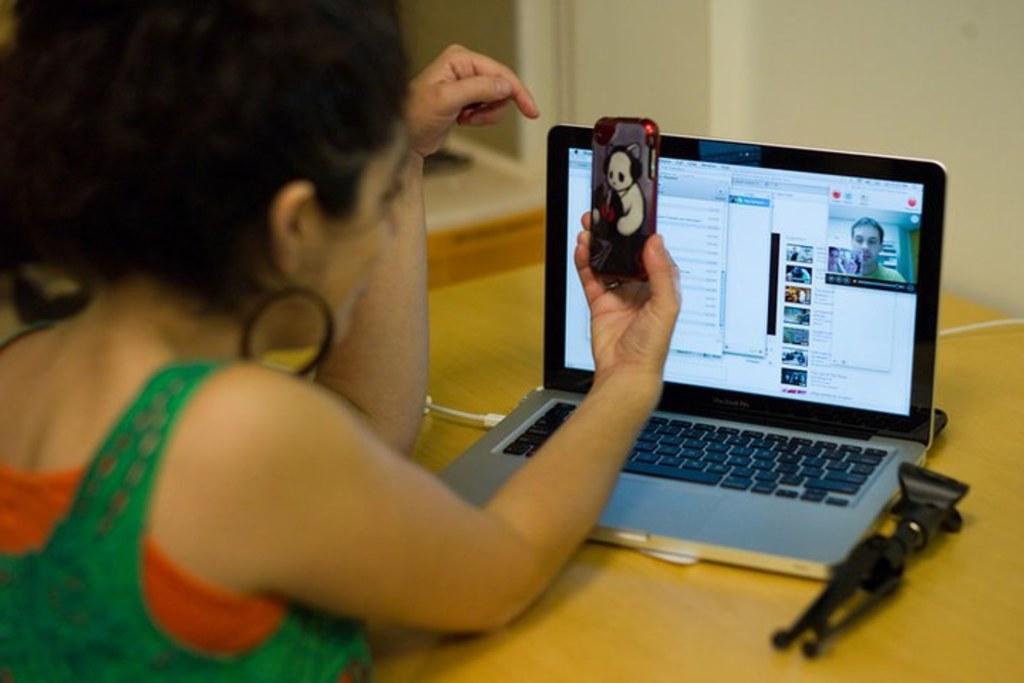How would you summarize this image in a sentence or two? In this Picture we can see that a girl is looking to her phone, laptop on the top of the table and cable, selfie stand beside it. Girl is wearing Green And orange gown which look very pretty on her. 